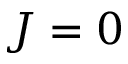<formula> <loc_0><loc_0><loc_500><loc_500>J = 0</formula> 